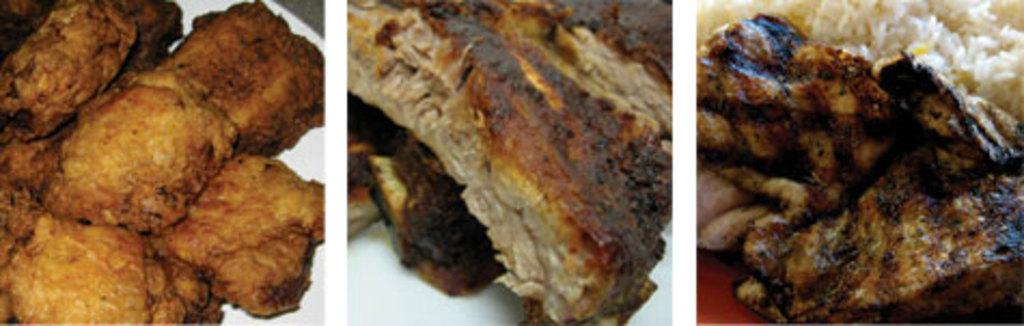What type of artwork is depicted in the image? The image is a collage. What subject matter is featured in the collage? The collage contains pictures of food. What advice is given by the street vendor in the image? There is no street vendor or advice present in the image; it is a collage of food pictures. 